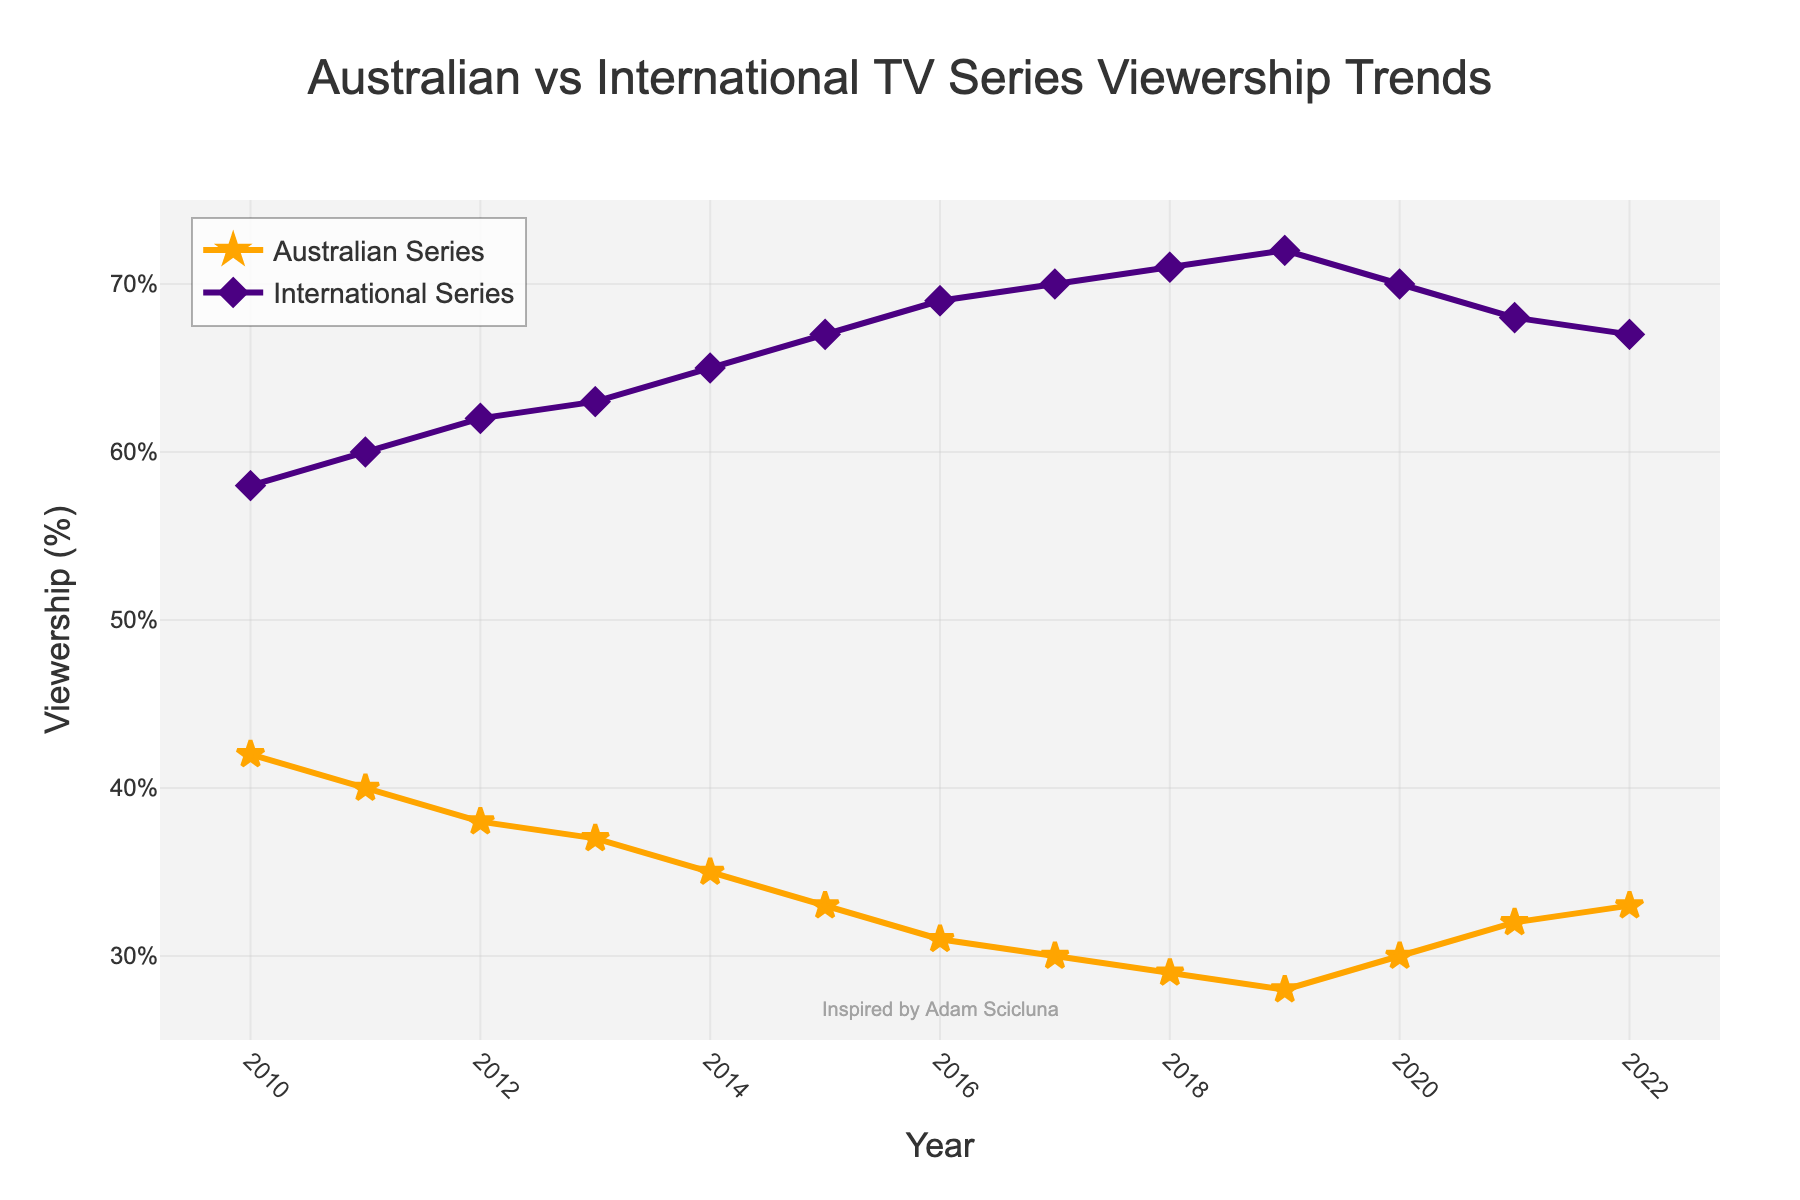What year did the viewership of Australian series reach its lowest point? The figure shows the trend over the years with percentages for Australian series viewership. The lowest point on the line representing Australian series is in 2019 with 28%.
Answer: 2019 In which year did the viewership of Australian series start to increase after continuously declining? Looking at the trend for Australian series, it declines uniformly from 2010 until 2019. It starts increasing in 2020.
Answer: 2020 By how many percentage points did the viewership of Australian series increase from 2019 to 2022? The viewership in 2019 is 28% and in 2022 it is 33%. Calculate the difference: 33% - 28% = 5%.
Answer: 5 Compare the viewership of both Australian and International series in 2021. Which had higher viewership and by how much? In 2021, the viewership of Australian series was 32%, and that of international series was 68%. Calculate the difference: 68% - 32% = 36%.
Answer: International series by 36% What is the overall trend for the viewership of international series from 2010 to 2022? The line representing international series viewership shows a general increasing trend from 2010 to 2018, peaking at 72% in 2019, followed by a slight decline but remains relatively high.
Answer: Increasing By how many percentage points did the viewership of Australian series decline from 2010 to 2019? Viewership in 2010 was 42% and in 2019 it was 28%. Calculate the difference: 42% - 28% = 14%.
Answer: 14 Which series had a viewership of 70% in 2017? The line marking viewership trends shows that international series reached 70% in 2017.
Answer: International series Between which two consecutive years did international series see the most significant increase in viewership? Check the differences in percentages for international series year over year. The most significant increase is between 2013 (63%) and 2014 (65%), which is 65% - 63% = 2%.
Answer: 2013 and 2014 On the graph, which visual properties distinguish the lines for Australian and International series? The line for Australian series is orange with star markers, while the line for international series is purple with diamond markers.
Answer: Color and marker type 